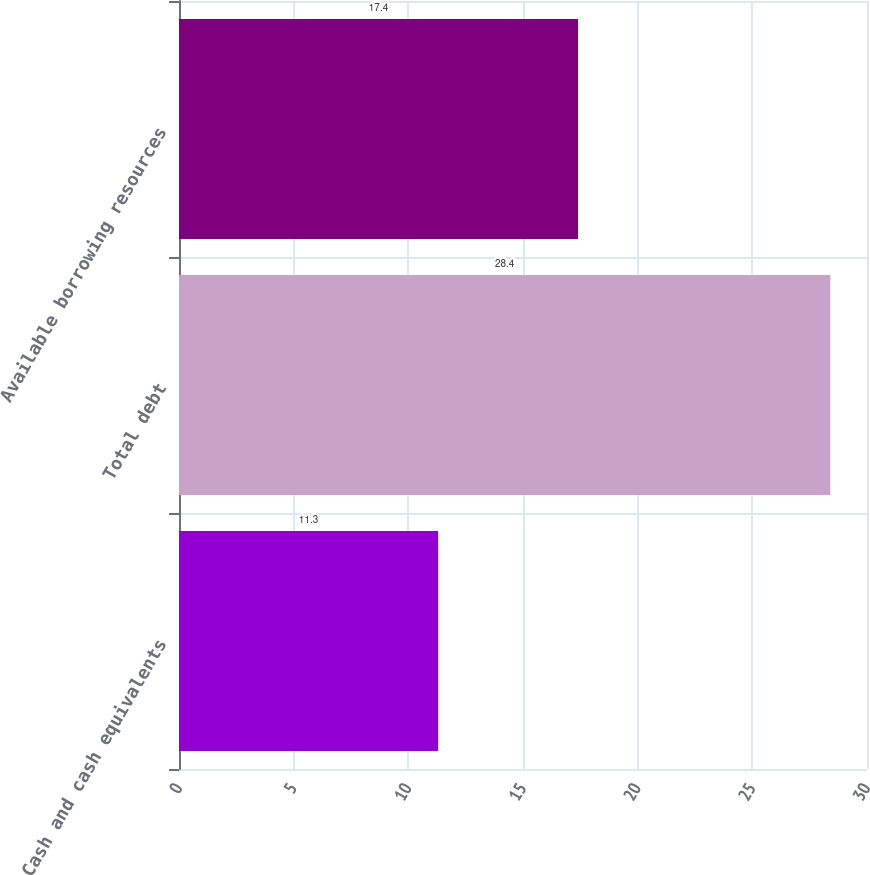<chart> <loc_0><loc_0><loc_500><loc_500><bar_chart><fcel>Cash and cash equivalents<fcel>Total debt<fcel>Available borrowing resources<nl><fcel>11.3<fcel>28.4<fcel>17.4<nl></chart> 